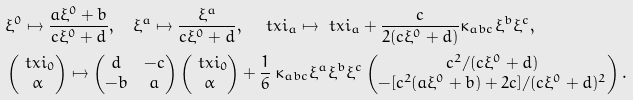<formula> <loc_0><loc_0><loc_500><loc_500>& \xi ^ { 0 } \mapsto \frac { a \xi ^ { 0 } + b } { c \xi ^ { 0 } + d } , \quad \xi ^ { a } \mapsto \frac { \xi ^ { a } } { c \xi ^ { 0 } + d } , \quad \ t x i _ { a } \mapsto \ t x i _ { a } + \frac { c } { 2 ( c \xi ^ { 0 } + d ) } \kappa _ { a b c } \xi ^ { b } \xi ^ { c } , \\ & \begin{pmatrix} \ t x i _ { 0 } \\ \alpha \end{pmatrix} \mapsto \begin{pmatrix} d & - c \\ - b & a \end{pmatrix} \begin{pmatrix} \ t x i _ { 0 } \\ \alpha \end{pmatrix} + \frac { 1 } { 6 } \, \kappa _ { a b c } \xi ^ { a } \xi ^ { b } \xi ^ { c } \begin{pmatrix} c ^ { 2 } / ( c \xi ^ { 0 } + d ) \\ - [ c ^ { 2 } ( a \xi ^ { 0 } + b ) + 2 c ] / ( c \xi ^ { 0 } + d ) ^ { 2 } \end{pmatrix} .</formula> 